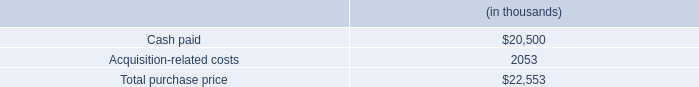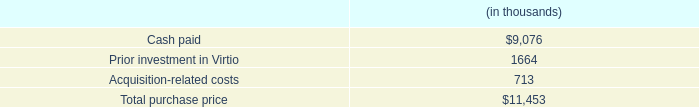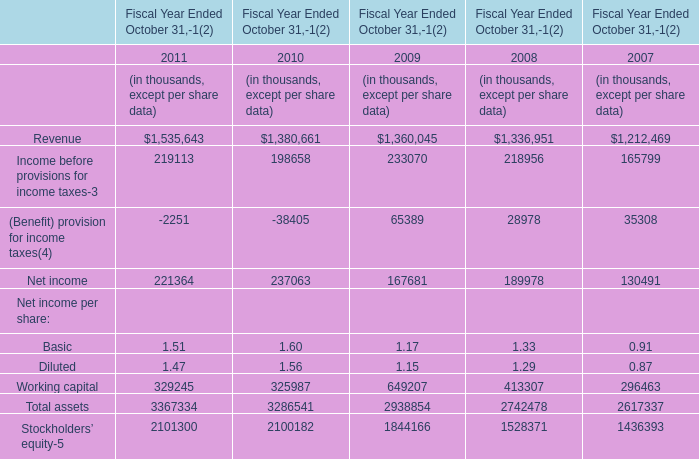what percentage of the total purchase price was intangible assets? 
Computations: ((6 * 1000) / 22553)
Answer: 0.26604. 